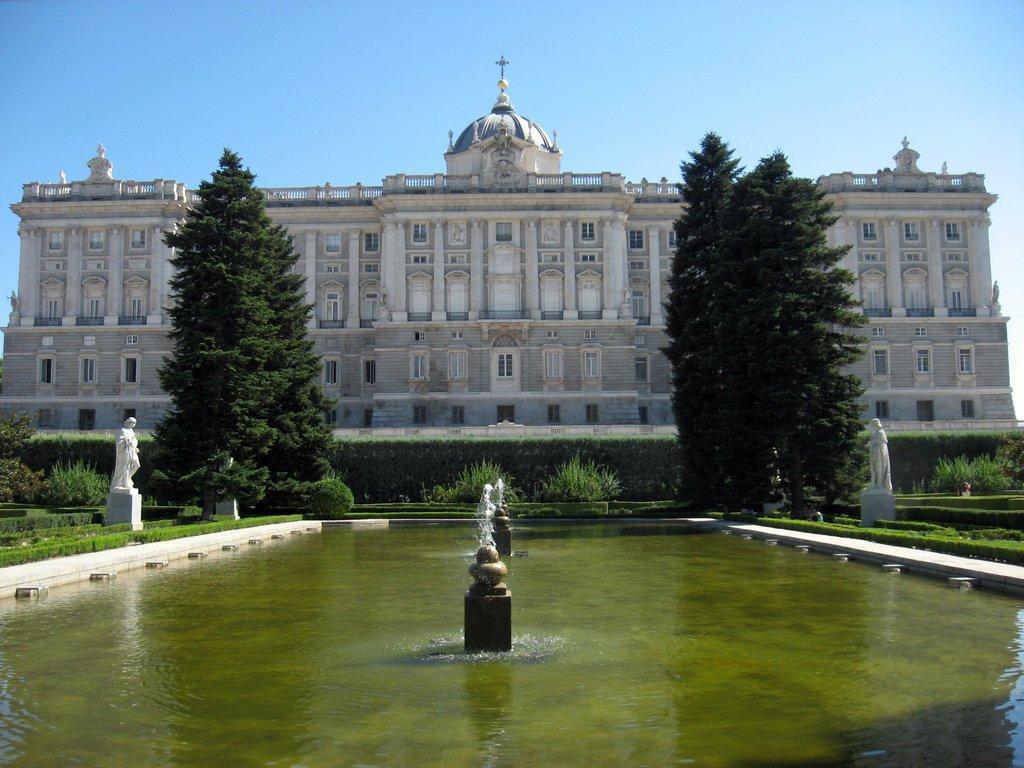Please provide a concise description of this image. In the image we can see the building and trees. Here we can see water fountains and sculptures. Here we can see grass, plant and the sky. 